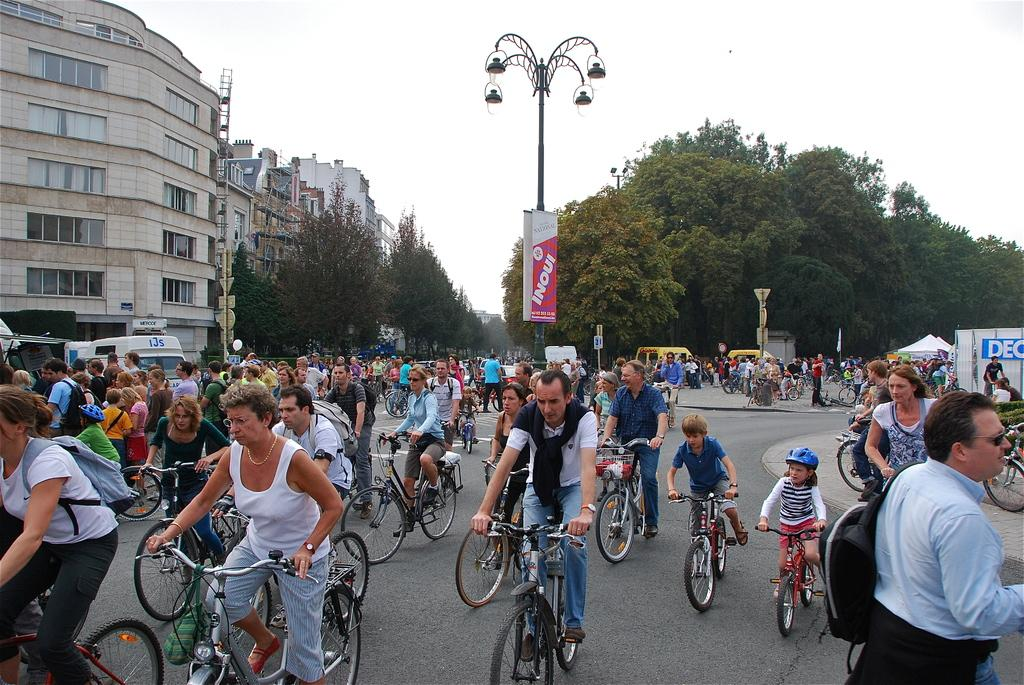What activity are the persons in the image engaged in? The persons in the image are doing cycling on the road. What can be seen in the background of the image? There are trees and buildings in the background of the image. What is visible in the sky in the image? The sky is visible in the image. What object can be seen in the image besides the persons and the background? There is a pole in the image. What type of toothpaste is being used by the cyclists in the image? There is no toothpaste present in the image; the persons are cycling on the road. What kind of paste is being applied to the buildings in the background? There is no paste being applied to the buildings in the background; they are simply visible in the image. 